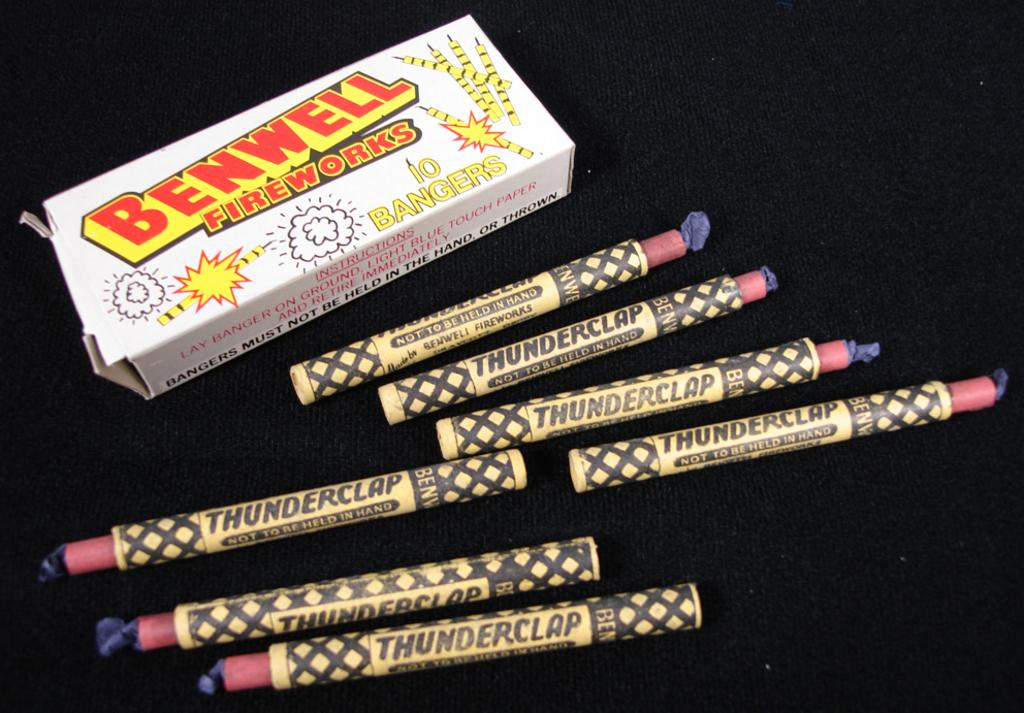<image>
Create a compact narrative representing the image presented. Many thunderclap fireworks are laid out next to a Benwell Fireworks box. 